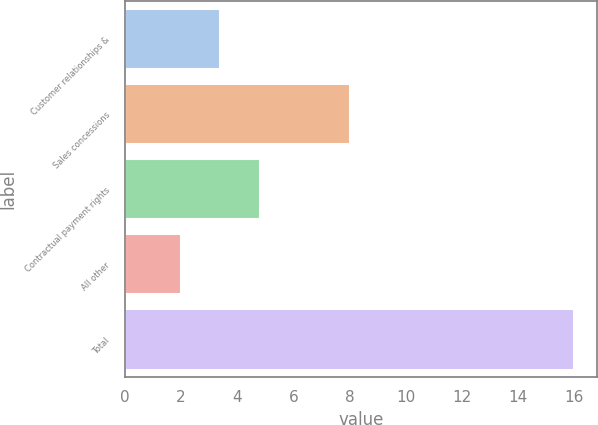<chart> <loc_0><loc_0><loc_500><loc_500><bar_chart><fcel>Customer relationships &<fcel>Sales concessions<fcel>Contractual payment rights<fcel>All other<fcel>Total<nl><fcel>3.4<fcel>8<fcel>4.8<fcel>2<fcel>16<nl></chart> 